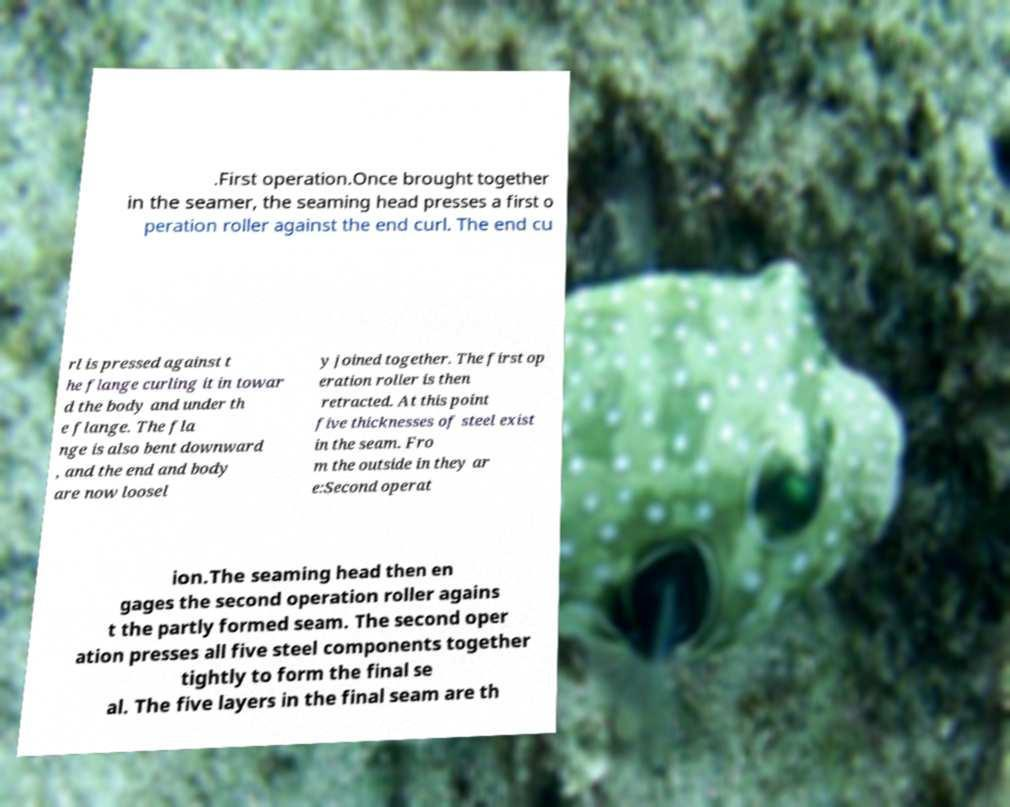Could you extract and type out the text from this image? .First operation.Once brought together in the seamer, the seaming head presses a first o peration roller against the end curl. The end cu rl is pressed against t he flange curling it in towar d the body and under th e flange. The fla nge is also bent downward , and the end and body are now loosel y joined together. The first op eration roller is then retracted. At this point five thicknesses of steel exist in the seam. Fro m the outside in they ar e:Second operat ion.The seaming head then en gages the second operation roller agains t the partly formed seam. The second oper ation presses all five steel components together tightly to form the final se al. The five layers in the final seam are th 